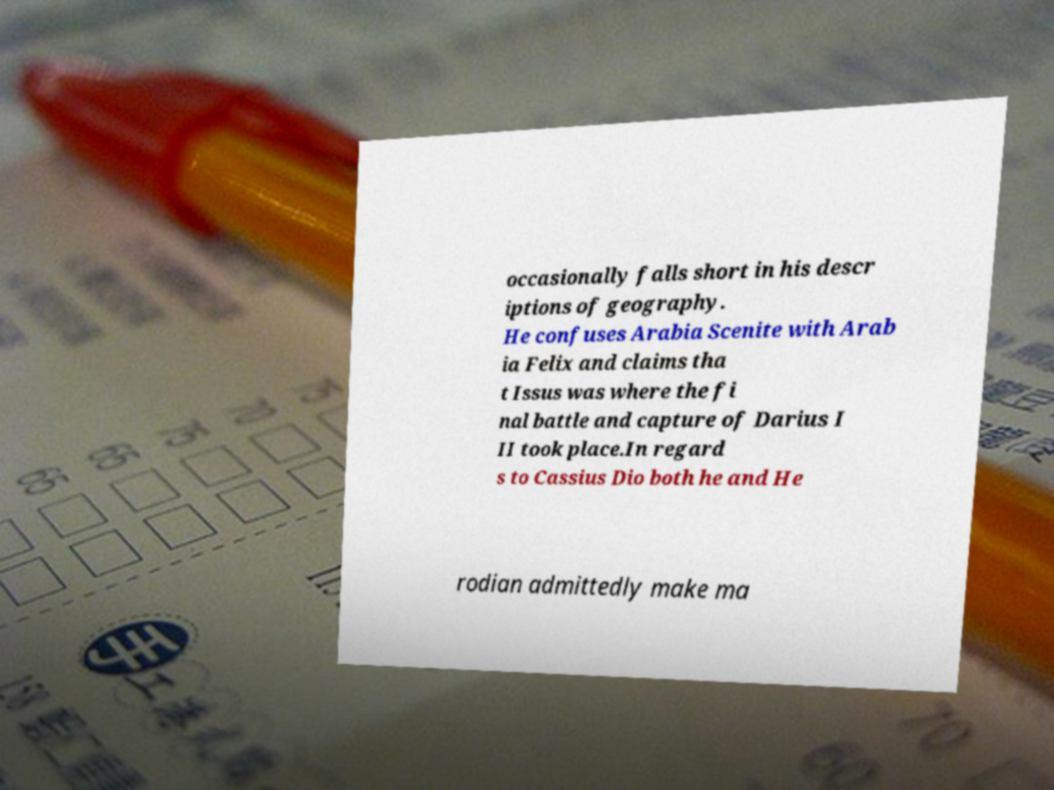Can you accurately transcribe the text from the provided image for me? occasionally falls short in his descr iptions of geography. He confuses Arabia Scenite with Arab ia Felix and claims tha t Issus was where the fi nal battle and capture of Darius I II took place.In regard s to Cassius Dio both he and He rodian admittedly make ma 